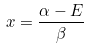<formula> <loc_0><loc_0><loc_500><loc_500>x = \frac { \alpha - E } { \beta }</formula> 